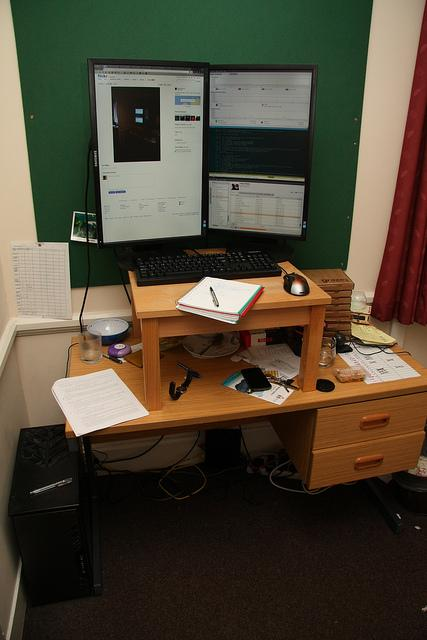Where does the black and silver item in the middle compartment belong? wrist 